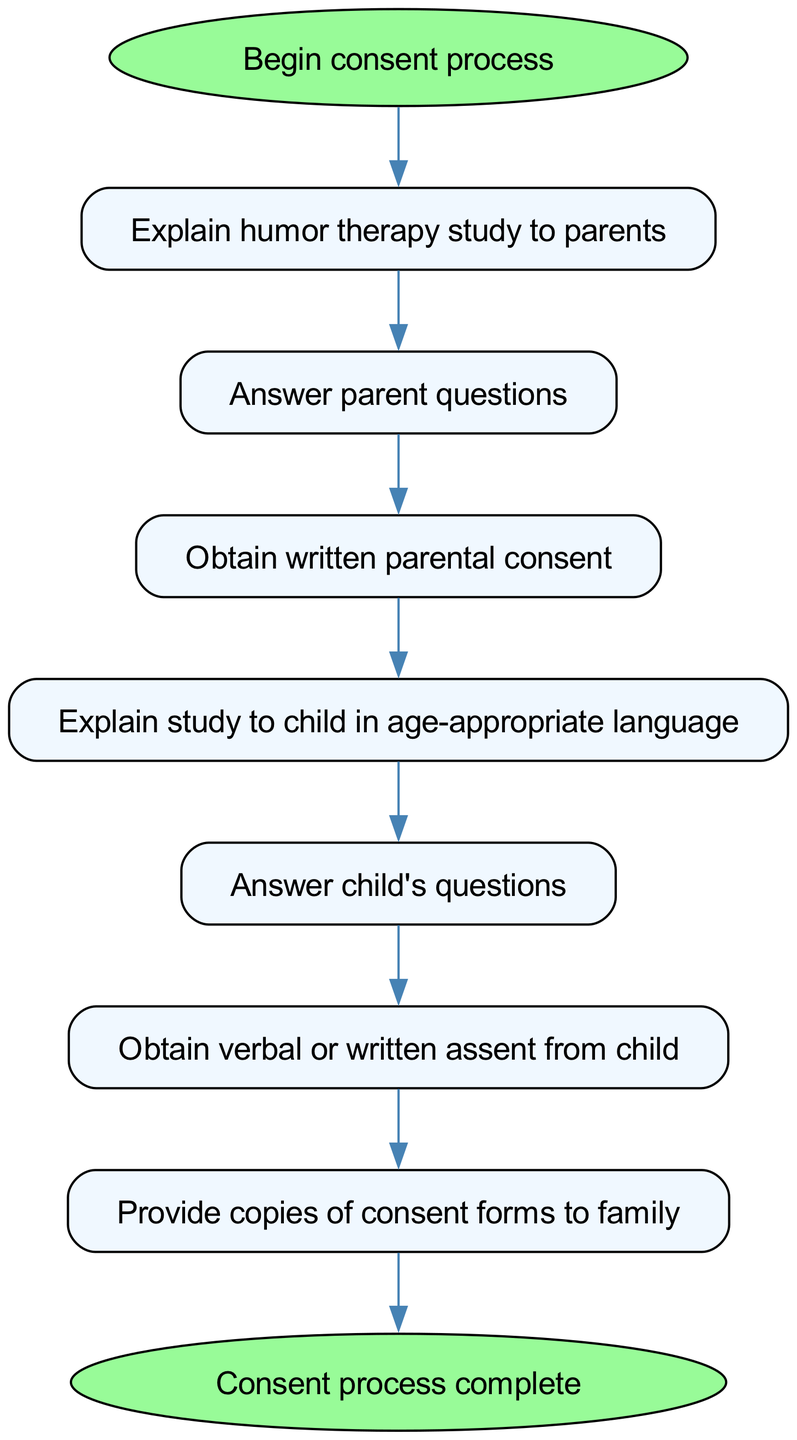What is the first step in the consent process? The first step is indicated by the "Begin consent process" node, which starts the flow of the diagram.
Answer: Begin consent process How many nodes are in the diagram? Counting all the unique elements listed in the diagram, there are eight nodes that represent different steps in the process.
Answer: Eight What step comes after explaining the study to the parents? The flow shows that after "Explain humor therapy study to parents," the next step is "Answer parent questions."
Answer: Answer parent questions What document is obtained from parents? The diagram notes that after answering parent questions, the next step is to "Obtain written parental consent," indicating that a consent document is required.
Answer: Written parental consent Which step involves the child’s participation directly? The step titled "Explain study to child in age-appropriate language" indicates the child’s direct participation in the consent process.
Answer: Explain study to child in age-appropriate language What must be obtained from the child after answering their questions? After satisfying the child's questions, the process specifies "Obtain verbal or written assent from child," indicating that the child's approval is needed next.
Answer: Verbal or written assent What does the diagram include at the end of the consent process? The final node in the diagram indicates the conclusion of the process, labeled "Consent process complete." This signifies that all necessary actions for consent have been fulfilled.
Answer: Consent process complete What is the second node in the flowchart? The second node directly following the start is labeled "Explain humor therapy study to parents," which is the next step after beginning the consent process.
Answer: Explain humor therapy study to parents What is provided to the family after obtaining consent? According to the final steps of the diagram, after obtaining assent from the child, the step instructs to "Provide copies of consent forms to family."
Answer: Copies of consent forms 